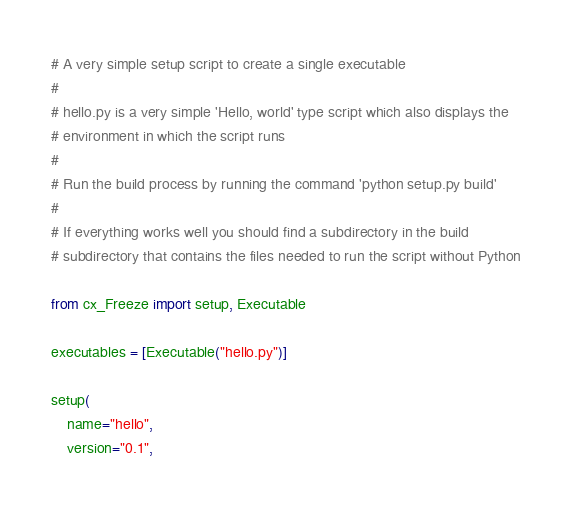<code> <loc_0><loc_0><loc_500><loc_500><_Python_># A very simple setup script to create a single executable
#
# hello.py is a very simple 'Hello, world' type script which also displays the
# environment in which the script runs
#
# Run the build process by running the command 'python setup.py build'
#
# If everything works well you should find a subdirectory in the build
# subdirectory that contains the files needed to run the script without Python

from cx_Freeze import setup, Executable

executables = [Executable("hello.py")]

setup(
    name="hello",
    version="0.1",</code> 